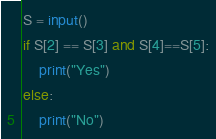Convert code to text. <code><loc_0><loc_0><loc_500><loc_500><_Python_>S = input()
if S[2] == S[3] and S[4]==S[5]:
    print("Yes")
else:
    print("No")</code> 